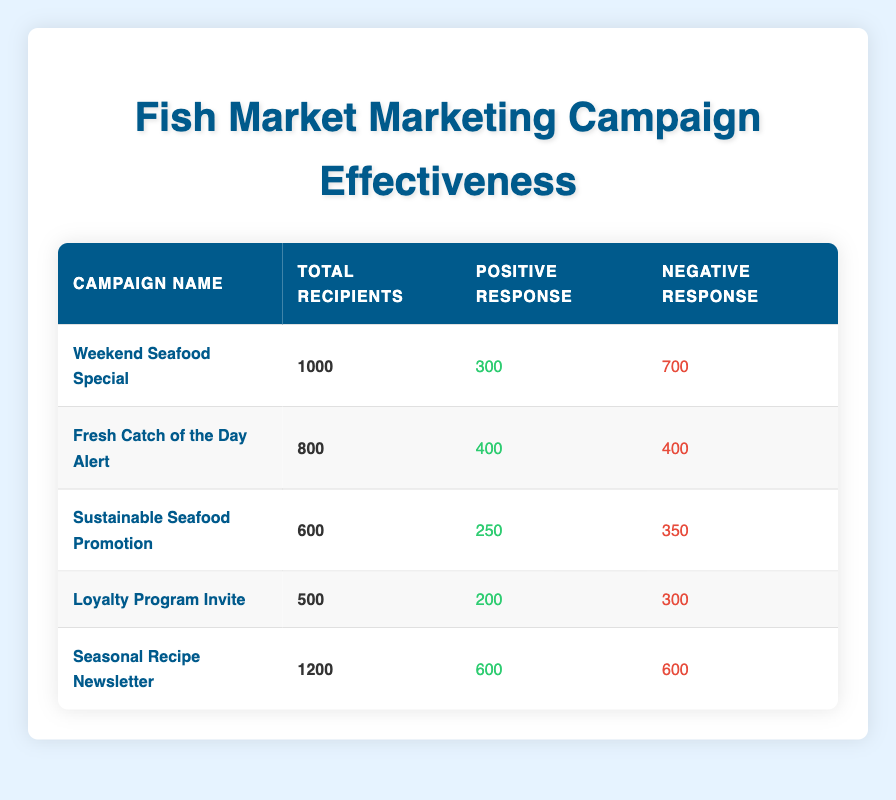What is the total number of recipients for the "Loyalty Program Invite" campaign? The table shows the total recipients for each campaign in the "Total Recipients" column. For "Loyalty Program Invite," the total recipients are listed as 500.
Answer: 500 What campaign had the highest positive response rate? To determine this, we need to compare the number of positive responses for each campaign. The campaign with the highest positive responses is "Fresh Catch of the Day Alert" with 400 positive responses.
Answer: Fresh Catch of the Day Alert What is the total number of positive responses across all campaigns? We can find the total positive responses by adding the positive responses from each campaign: 300 + 400 + 250 + 200 + 600 = 1850.
Answer: 1850 Did "Weekend Seafood Special" receive more positive responses than "Sustainable Seafood Promotion"? The table indicates that "Weekend Seafood Special" had 300 positive responses, while "Sustainable Seafood Promotion" had 250. Since 300 is greater than 250, the statement is true.
Answer: Yes What is the average number of negative responses per campaign? To calculate the average negative responses, we first sum the negative responses: 700 + 400 + 350 + 300 + 600 = 2350. There are 5 campaigns, so we divide: 2350 / 5 = 470.
Answer: 470 Which campaign had a 50% or higher positive response rate? For this, we calculate the response rate for each campaign by dividing the number of positive responses by the total recipients: - Weekend Seafood Special: 300/1000 = 30% - Fresh Catch of the Day Alert: 400/800 = 50% - Sustainable Seafood Promotion: 250/600 ≈ 41.67% - Loyalty Program Invite: 200/500 = 40% - Seasonal Recipe Newsletter: 600/1200 = 50% Positive response rates at or above 50% are found in "Fresh Catch of the Day Alert," "Seasonal Recipe Newsletter."
Answer: Fresh Catch of the Day Alert, Seasonal Recipe Newsletter How many more negative responses did the "Weekend Seafood Special" have compared to "Loyalty Program Invite"? The negative responses for "Weekend Seafood Special" are 700, while for "Loyalty Program Invite," they are 300. The difference is 700 - 300 = 400.
Answer: 400 What is the total response count for the "Seasonal Recipe Newsletter"? The total response count includes both positive and negative responses. For "Seasonal Recipe Newsletter," the positive responses are 600 and negative responses are 600, giving a total of 600 + 600 = 1200.
Answer: 1200 Which campaign had the least number of total recipients? We look at the "Total Recipients" column and find that the "Loyalty Program Invite" campaign had the least, with 500 total recipients.
Answer: Loyalty Program Invite 